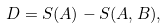<formula> <loc_0><loc_0><loc_500><loc_500>D = S ( A ) - S ( A , B ) ,</formula> 